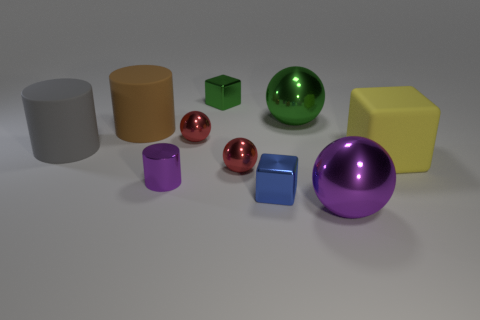Is the shiny cylinder the same color as the large cube?
Your answer should be very brief. No. What is the shape of the small green thing?
Give a very brief answer. Cube. Are there fewer big brown matte things to the left of the large yellow matte cube than small brown metal things?
Your answer should be very brief. No. Do the small shiny cube in front of the yellow matte object and the small metallic cylinder have the same color?
Your answer should be compact. No. How many rubber things are tiny gray things or big green things?
Make the answer very short. 0. Is there anything else that has the same size as the green shiny block?
Offer a very short reply. Yes. The other large object that is made of the same material as the big green thing is what color?
Keep it short and to the point. Purple. How many blocks are either small brown matte objects or brown things?
Make the answer very short. 0. What number of things are large balls or large objects that are on the left side of the blue block?
Make the answer very short. 4. Is there a brown cylinder?
Your response must be concise. Yes. 